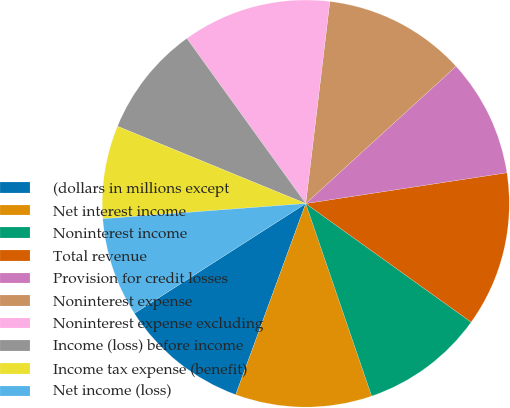Convert chart. <chart><loc_0><loc_0><loc_500><loc_500><pie_chart><fcel>(dollars in millions except<fcel>Net interest income<fcel>Noninterest income<fcel>Total revenue<fcel>Provision for credit losses<fcel>Noninterest expense<fcel>Noninterest expense excluding<fcel>Income (loss) before income<fcel>Income tax expense (benefit)<fcel>Net income (loss)<nl><fcel>10.34%<fcel>10.84%<fcel>9.85%<fcel>12.32%<fcel>9.36%<fcel>11.33%<fcel>11.82%<fcel>8.87%<fcel>7.39%<fcel>7.88%<nl></chart> 